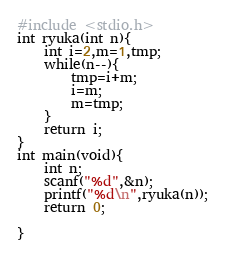<code> <loc_0><loc_0><loc_500><loc_500><_C_>#include <stdio.h>
int ryuka(int n){
    int i=2,m=1,tmp;
    while(n--){
        tmp=i+m;
        i=m;
        m=tmp;
    }
    return i;
}
int main(void){
    int n;
    scanf("%d",&n);
    printf("%d\n",ryuka(n));
    return 0;
    
}
</code> 